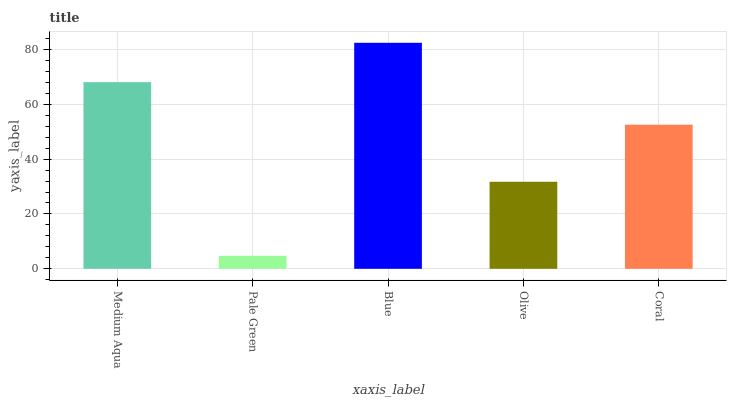Is Blue the minimum?
Answer yes or no. No. Is Pale Green the maximum?
Answer yes or no. No. Is Blue greater than Pale Green?
Answer yes or no. Yes. Is Pale Green less than Blue?
Answer yes or no. Yes. Is Pale Green greater than Blue?
Answer yes or no. No. Is Blue less than Pale Green?
Answer yes or no. No. Is Coral the high median?
Answer yes or no. Yes. Is Coral the low median?
Answer yes or no. Yes. Is Olive the high median?
Answer yes or no. No. Is Blue the low median?
Answer yes or no. No. 